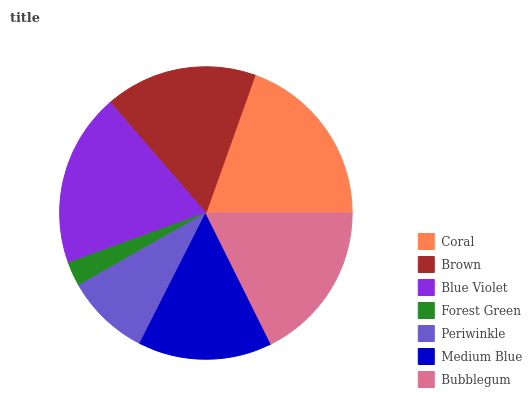Is Forest Green the minimum?
Answer yes or no. Yes. Is Coral the maximum?
Answer yes or no. Yes. Is Brown the minimum?
Answer yes or no. No. Is Brown the maximum?
Answer yes or no. No. Is Coral greater than Brown?
Answer yes or no. Yes. Is Brown less than Coral?
Answer yes or no. Yes. Is Brown greater than Coral?
Answer yes or no. No. Is Coral less than Brown?
Answer yes or no. No. Is Brown the high median?
Answer yes or no. Yes. Is Brown the low median?
Answer yes or no. Yes. Is Blue Violet the high median?
Answer yes or no. No. Is Medium Blue the low median?
Answer yes or no. No. 